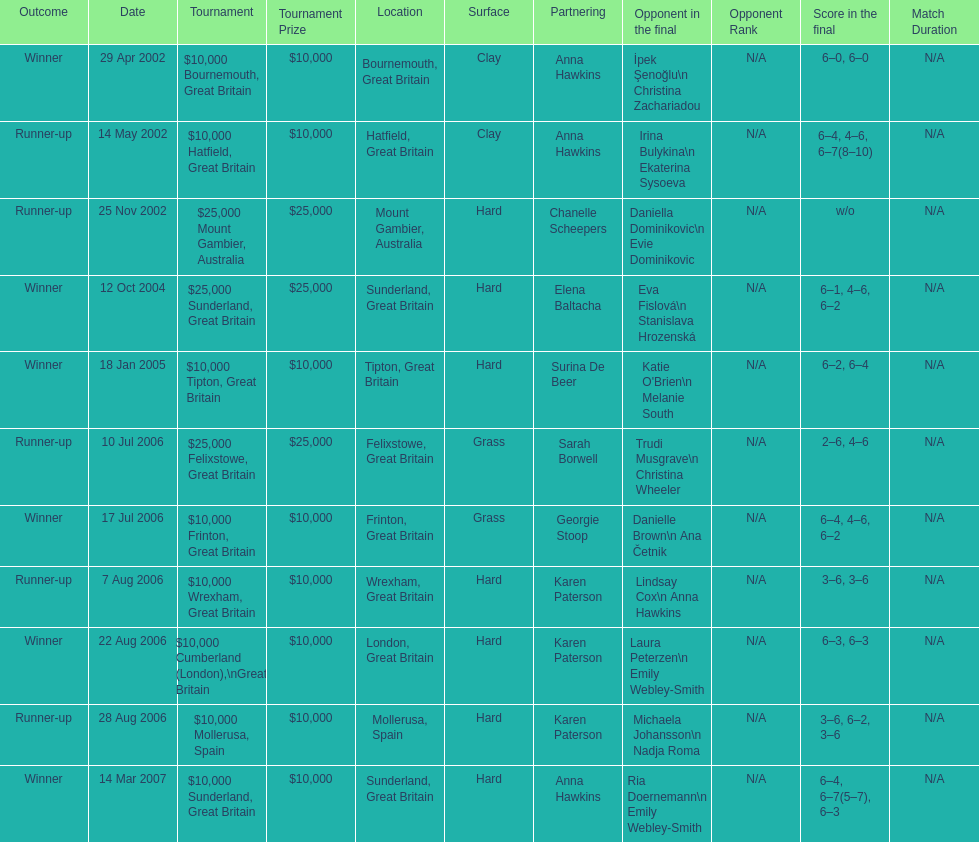How many tournaments has jane o'donoghue competed in? 11. Could you parse the entire table as a dict? {'header': ['Outcome', 'Date', 'Tournament', 'Tournament Prize', 'Location', 'Surface', 'Partnering', 'Opponent in the final', 'Opponent Rank', 'Score in the final', 'Match Duration'], 'rows': [['Winner', '29 Apr 2002', '$10,000 Bournemouth, Great Britain', '$10,000', 'Bournemouth, Great Britain', 'Clay', 'Anna Hawkins', 'İpek Şenoğlu\\n Christina Zachariadou', 'N/A', '6–0, 6–0', 'N/A'], ['Runner-up', '14 May 2002', '$10,000 Hatfield, Great Britain', '$10,000', 'Hatfield, Great Britain', 'Clay', 'Anna Hawkins', 'Irina Bulykina\\n Ekaterina Sysoeva', 'N/A', '6–4, 4–6, 6–7(8–10)', 'N/A'], ['Runner-up', '25 Nov 2002', '$25,000 Mount Gambier, Australia', '$25,000', 'Mount Gambier, Australia', 'Hard', 'Chanelle Scheepers', 'Daniella Dominikovic\\n Evie Dominikovic', 'N/A', 'w/o', 'N/A'], ['Winner', '12 Oct 2004', '$25,000 Sunderland, Great Britain', '$25,000', 'Sunderland, Great Britain', 'Hard', 'Elena Baltacha', 'Eva Fislová\\n Stanislava Hrozenská', 'N/A', '6–1, 4–6, 6–2', 'N/A'], ['Winner', '18 Jan 2005', '$10,000 Tipton, Great Britain', '$10,000', 'Tipton, Great Britain', 'Hard', 'Surina De Beer', "Katie O'Brien\\n Melanie South", 'N/A', '6–2, 6–4', 'N/A'], ['Runner-up', '10 Jul 2006', '$25,000 Felixstowe, Great Britain', '$25,000', 'Felixstowe, Great Britain', 'Grass', 'Sarah Borwell', 'Trudi Musgrave\\n Christina Wheeler', 'N/A', '2–6, 4–6', 'N/A'], ['Winner', '17 Jul 2006', '$10,000 Frinton, Great Britain', '$10,000', 'Frinton, Great Britain', 'Grass', 'Georgie Stoop', 'Danielle Brown\\n Ana Četnik', 'N/A', '6–4, 4–6, 6–2', 'N/A'], ['Runner-up', '7 Aug 2006', '$10,000 Wrexham, Great Britain', '$10,000', 'Wrexham, Great Britain', 'Hard', 'Karen Paterson', 'Lindsay Cox\\n Anna Hawkins', 'N/A', '3–6, 3–6', 'N/A'], ['Winner', '22 Aug 2006', '$10,000 Cumberland (London),\\nGreat Britain', '$10,000', 'London, Great Britain', 'Hard', 'Karen Paterson', 'Laura Peterzen\\n Emily Webley-Smith', 'N/A', '6–3, 6–3', 'N/A'], ['Runner-up', '28 Aug 2006', '$10,000 Mollerusa, Spain', '$10,000', 'Mollerusa, Spain', 'Hard', 'Karen Paterson', 'Michaela Johansson\\n Nadja Roma', 'N/A', '3–6, 6–2, 3–6', 'N/A'], ['Winner', '14 Mar 2007', '$10,000 Sunderland, Great Britain', '$10,000', 'Sunderland, Great Britain', 'Hard', 'Anna Hawkins', 'Ria Doernemann\\n Emily Webley-Smith', 'N/A', '6–4, 6–7(5–7), 6–3', 'N/A']]} 